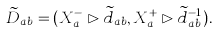Convert formula to latex. <formula><loc_0><loc_0><loc_500><loc_500>\widetilde { D } _ { a b } = ( X ^ { - } _ { a } \rhd \widetilde { d } _ { a b } , X ^ { + } _ { a } \rhd \widetilde { d } _ { a b } ^ { - 1 } ) .</formula> 